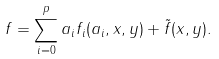Convert formula to latex. <formula><loc_0><loc_0><loc_500><loc_500>f = \sum _ { i = 0 } ^ { p } a _ { i } f _ { i } ( a _ { i } , x , y ) + \tilde { f } ( x , y ) .</formula> 